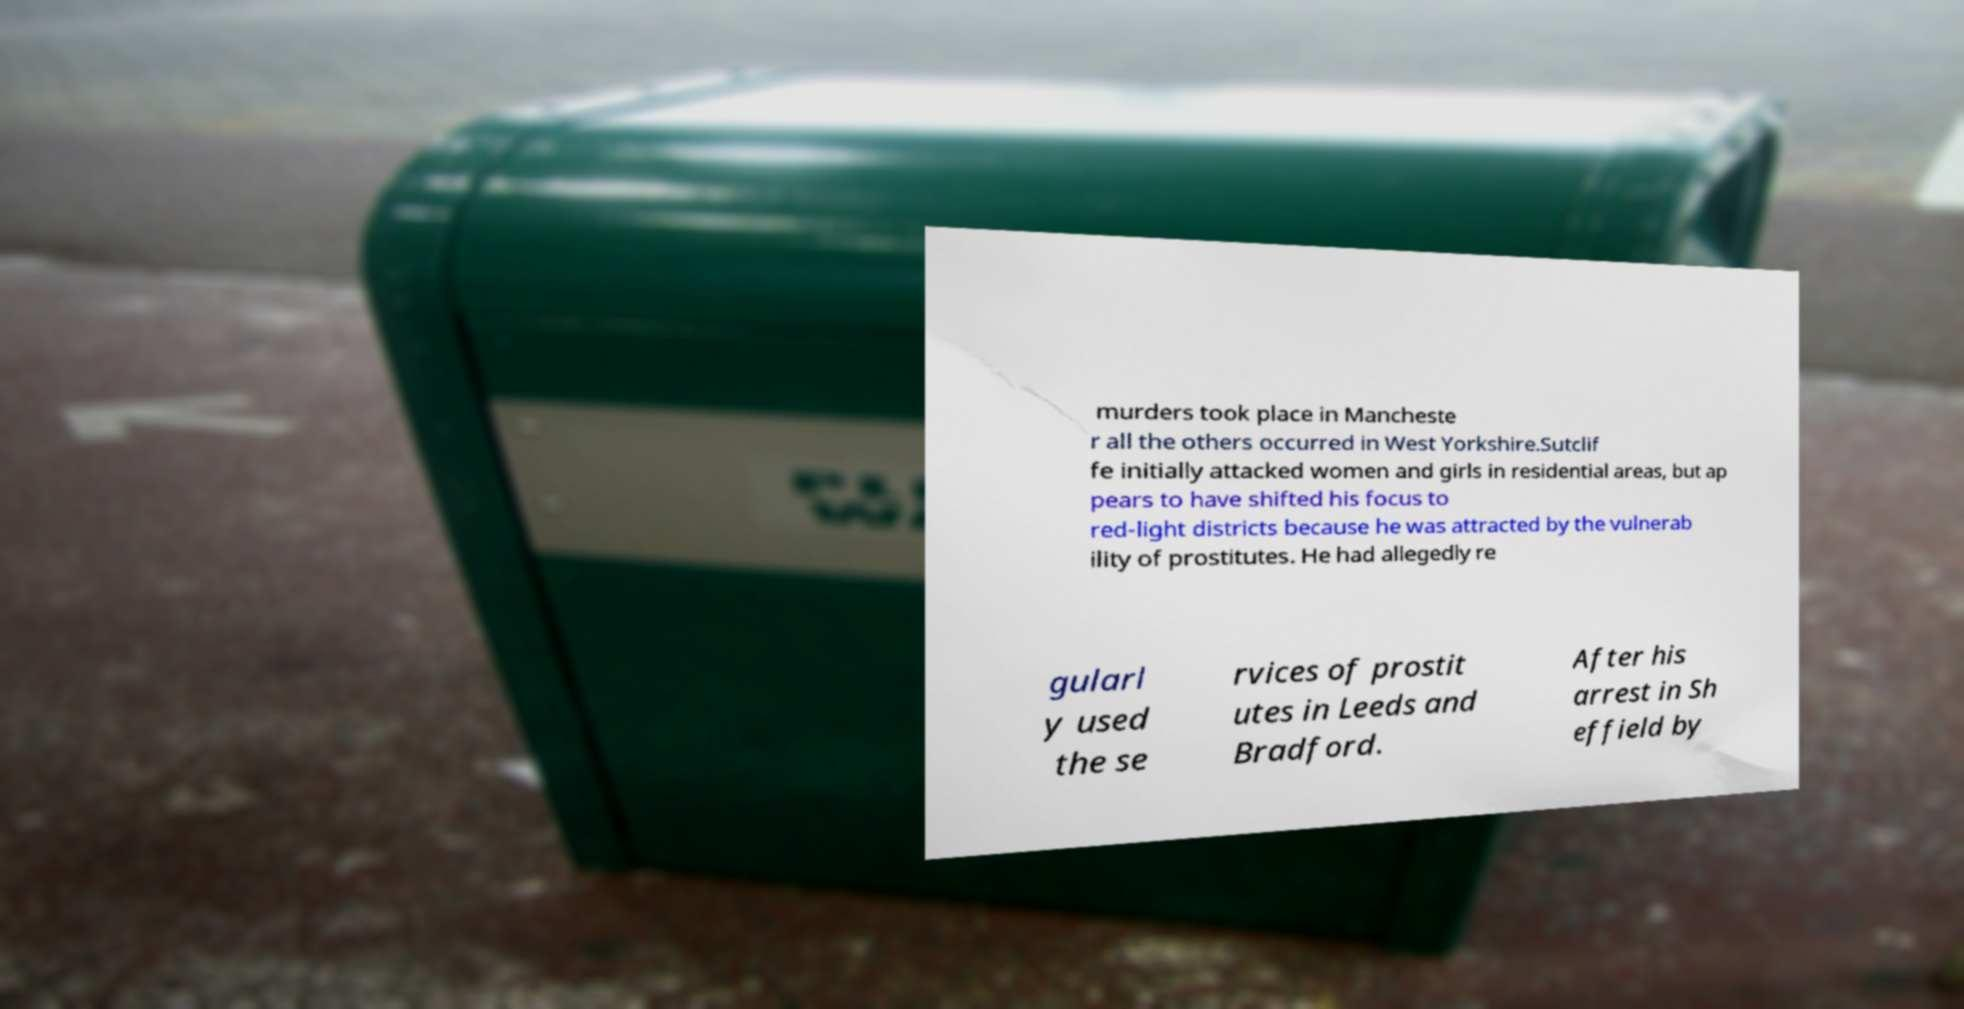Please read and relay the text visible in this image. What does it say? murders took place in Mancheste r all the others occurred in West Yorkshire.Sutclif fe initially attacked women and girls in residential areas, but ap pears to have shifted his focus to red-light districts because he was attracted by the vulnerab ility of prostitutes. He had allegedly re gularl y used the se rvices of prostit utes in Leeds and Bradford. After his arrest in Sh effield by 